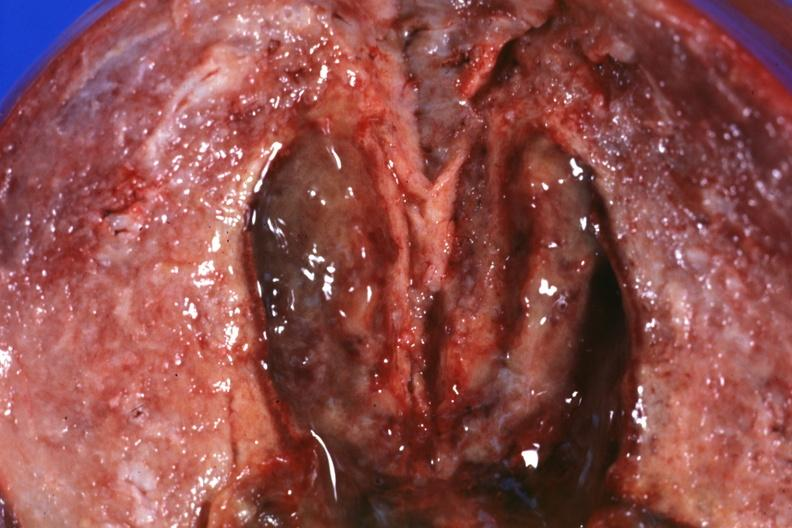does aorta show close-up view of 5 weeks post section 29yobf hypertension and brain hemorrhage?
Answer the question using a single word or phrase. No 